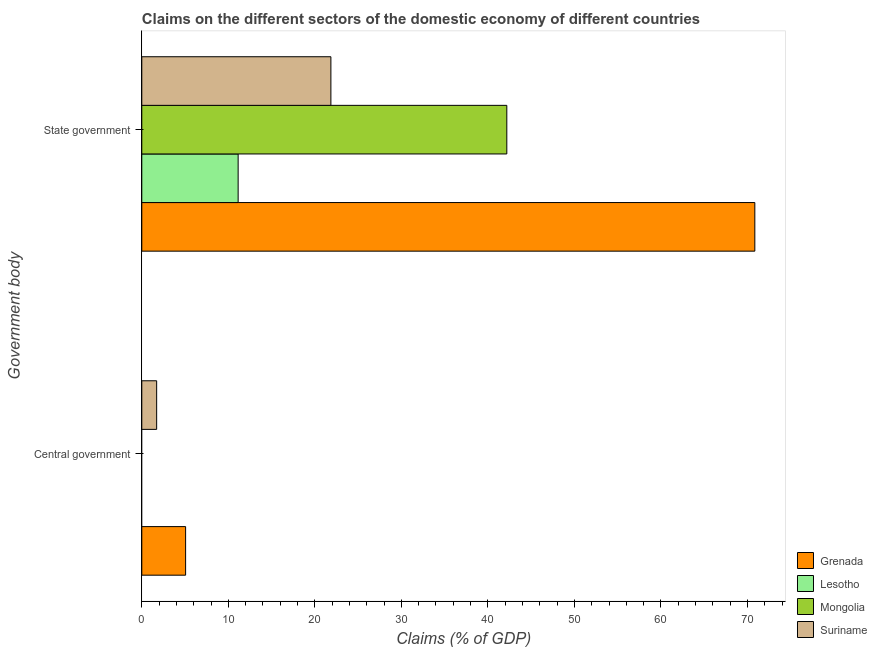How many different coloured bars are there?
Keep it short and to the point. 4. Are the number of bars on each tick of the Y-axis equal?
Offer a very short reply. No. What is the label of the 1st group of bars from the top?
Give a very brief answer. State government. What is the claims on state government in Suriname?
Offer a terse response. 21.85. Across all countries, what is the maximum claims on state government?
Keep it short and to the point. 70.85. Across all countries, what is the minimum claims on central government?
Provide a succinct answer. 0. In which country was the claims on state government maximum?
Ensure brevity in your answer.  Grenada. What is the total claims on central government in the graph?
Your response must be concise. 6.78. What is the difference between the claims on central government in Grenada and that in Suriname?
Offer a terse response. 3.35. What is the difference between the claims on state government in Suriname and the claims on central government in Lesotho?
Ensure brevity in your answer.  21.85. What is the average claims on state government per country?
Make the answer very short. 36.51. What is the difference between the claims on central government and claims on state government in Grenada?
Offer a terse response. -65.79. What is the ratio of the claims on state government in Grenada to that in Lesotho?
Ensure brevity in your answer.  6.36. Is the claims on state government in Suriname less than that in Lesotho?
Your response must be concise. No. Are all the bars in the graph horizontal?
Offer a very short reply. Yes. Are the values on the major ticks of X-axis written in scientific E-notation?
Offer a terse response. No. Does the graph contain any zero values?
Your answer should be very brief. Yes. Where does the legend appear in the graph?
Your response must be concise. Bottom right. How are the legend labels stacked?
Ensure brevity in your answer.  Vertical. What is the title of the graph?
Your answer should be compact. Claims on the different sectors of the domestic economy of different countries. What is the label or title of the X-axis?
Your answer should be compact. Claims (% of GDP). What is the label or title of the Y-axis?
Your response must be concise. Government body. What is the Claims (% of GDP) in Grenada in Central government?
Your response must be concise. 5.06. What is the Claims (% of GDP) in Lesotho in Central government?
Your answer should be very brief. 0. What is the Claims (% of GDP) in Suriname in Central government?
Keep it short and to the point. 1.72. What is the Claims (% of GDP) in Grenada in State government?
Offer a very short reply. 70.85. What is the Claims (% of GDP) of Lesotho in State government?
Offer a terse response. 11.14. What is the Claims (% of GDP) in Mongolia in State government?
Keep it short and to the point. 42.19. What is the Claims (% of GDP) in Suriname in State government?
Provide a short and direct response. 21.85. Across all Government body, what is the maximum Claims (% of GDP) of Grenada?
Make the answer very short. 70.85. Across all Government body, what is the maximum Claims (% of GDP) of Lesotho?
Offer a terse response. 11.14. Across all Government body, what is the maximum Claims (% of GDP) of Mongolia?
Provide a succinct answer. 42.19. Across all Government body, what is the maximum Claims (% of GDP) of Suriname?
Provide a short and direct response. 21.85. Across all Government body, what is the minimum Claims (% of GDP) of Grenada?
Your answer should be very brief. 5.06. Across all Government body, what is the minimum Claims (% of GDP) of Suriname?
Give a very brief answer. 1.72. What is the total Claims (% of GDP) of Grenada in the graph?
Offer a terse response. 75.91. What is the total Claims (% of GDP) in Lesotho in the graph?
Offer a terse response. 11.14. What is the total Claims (% of GDP) of Mongolia in the graph?
Offer a terse response. 42.19. What is the total Claims (% of GDP) in Suriname in the graph?
Provide a succinct answer. 23.57. What is the difference between the Claims (% of GDP) in Grenada in Central government and that in State government?
Your answer should be compact. -65.79. What is the difference between the Claims (% of GDP) in Suriname in Central government and that in State government?
Your response must be concise. -20.14. What is the difference between the Claims (% of GDP) of Grenada in Central government and the Claims (% of GDP) of Lesotho in State government?
Offer a terse response. -6.07. What is the difference between the Claims (% of GDP) in Grenada in Central government and the Claims (% of GDP) in Mongolia in State government?
Make the answer very short. -37.12. What is the difference between the Claims (% of GDP) of Grenada in Central government and the Claims (% of GDP) of Suriname in State government?
Offer a very short reply. -16.79. What is the average Claims (% of GDP) of Grenada per Government body?
Your response must be concise. 37.96. What is the average Claims (% of GDP) of Lesotho per Government body?
Your answer should be very brief. 5.57. What is the average Claims (% of GDP) in Mongolia per Government body?
Ensure brevity in your answer.  21.09. What is the average Claims (% of GDP) of Suriname per Government body?
Keep it short and to the point. 11.79. What is the difference between the Claims (% of GDP) of Grenada and Claims (% of GDP) of Suriname in Central government?
Your response must be concise. 3.35. What is the difference between the Claims (% of GDP) in Grenada and Claims (% of GDP) in Lesotho in State government?
Offer a very short reply. 59.72. What is the difference between the Claims (% of GDP) in Grenada and Claims (% of GDP) in Mongolia in State government?
Your answer should be compact. 28.66. What is the difference between the Claims (% of GDP) in Grenada and Claims (% of GDP) in Suriname in State government?
Your answer should be very brief. 49. What is the difference between the Claims (% of GDP) in Lesotho and Claims (% of GDP) in Mongolia in State government?
Your response must be concise. -31.05. What is the difference between the Claims (% of GDP) of Lesotho and Claims (% of GDP) of Suriname in State government?
Your answer should be very brief. -10.72. What is the difference between the Claims (% of GDP) in Mongolia and Claims (% of GDP) in Suriname in State government?
Your answer should be very brief. 20.33. What is the ratio of the Claims (% of GDP) of Grenada in Central government to that in State government?
Your response must be concise. 0.07. What is the ratio of the Claims (% of GDP) in Suriname in Central government to that in State government?
Offer a terse response. 0.08. What is the difference between the highest and the second highest Claims (% of GDP) in Grenada?
Provide a succinct answer. 65.79. What is the difference between the highest and the second highest Claims (% of GDP) of Suriname?
Offer a terse response. 20.14. What is the difference between the highest and the lowest Claims (% of GDP) of Grenada?
Your answer should be compact. 65.79. What is the difference between the highest and the lowest Claims (% of GDP) in Lesotho?
Your answer should be compact. 11.14. What is the difference between the highest and the lowest Claims (% of GDP) in Mongolia?
Your answer should be compact. 42.19. What is the difference between the highest and the lowest Claims (% of GDP) in Suriname?
Your answer should be compact. 20.14. 